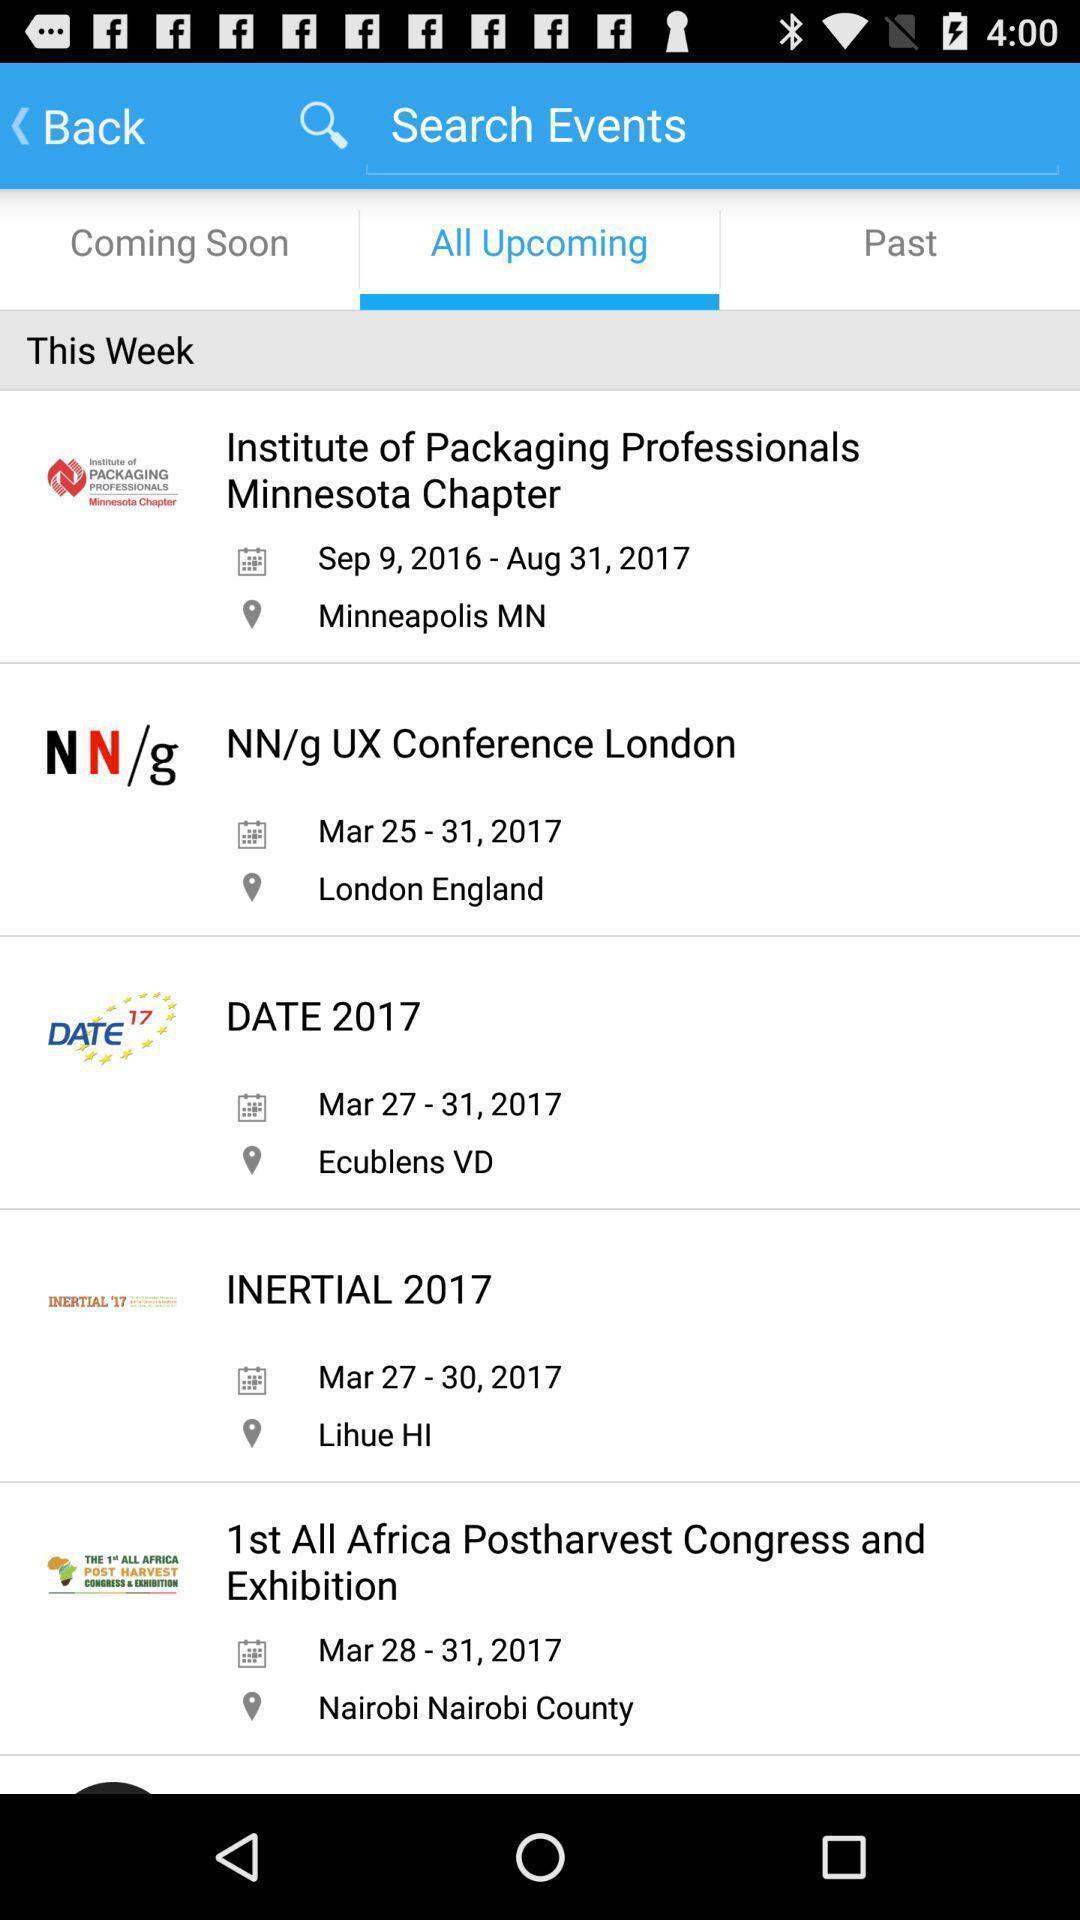What is the overall content of this screenshot? Screen shows search events. 